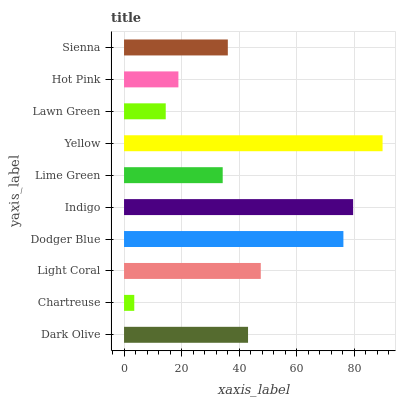Is Chartreuse the minimum?
Answer yes or no. Yes. Is Yellow the maximum?
Answer yes or no. Yes. Is Light Coral the minimum?
Answer yes or no. No. Is Light Coral the maximum?
Answer yes or no. No. Is Light Coral greater than Chartreuse?
Answer yes or no. Yes. Is Chartreuse less than Light Coral?
Answer yes or no. Yes. Is Chartreuse greater than Light Coral?
Answer yes or no. No. Is Light Coral less than Chartreuse?
Answer yes or no. No. Is Dark Olive the high median?
Answer yes or no. Yes. Is Sienna the low median?
Answer yes or no. Yes. Is Hot Pink the high median?
Answer yes or no. No. Is Dark Olive the low median?
Answer yes or no. No. 